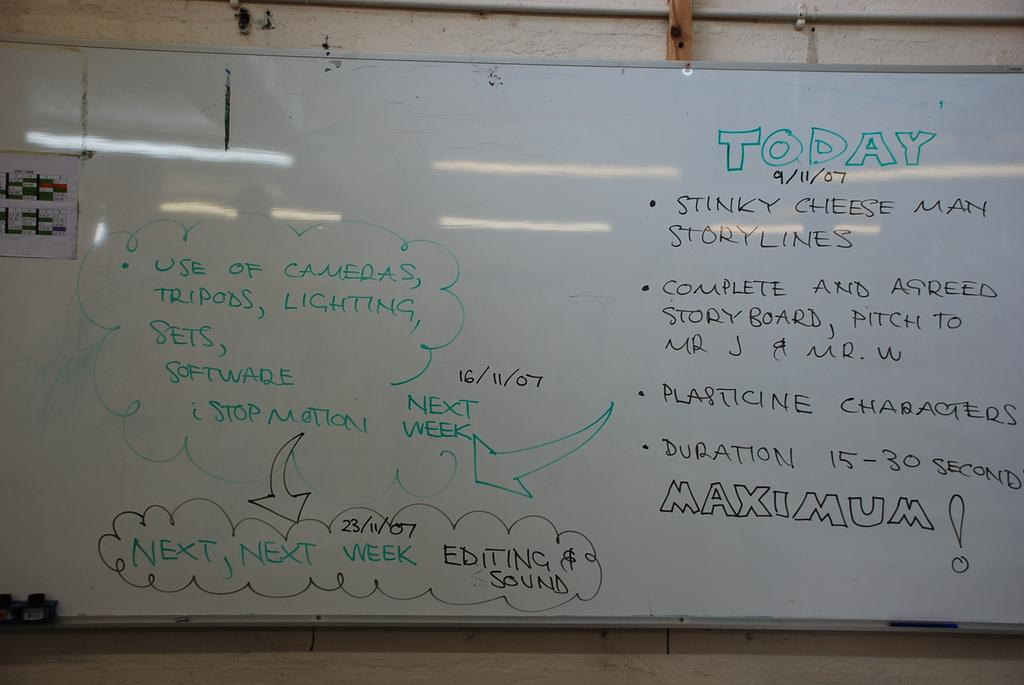<image>
Offer a succinct explanation of the picture presented. A white board shows today's agenda and other scribbles showing the plans for the video. 